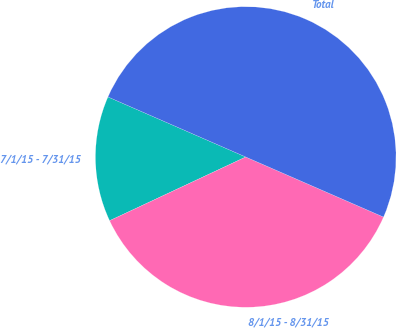Convert chart to OTSL. <chart><loc_0><loc_0><loc_500><loc_500><pie_chart><fcel>7/1/15 - 7/31/15<fcel>8/1/15 - 8/31/15<fcel>Total<nl><fcel>13.51%<fcel>36.49%<fcel>50.0%<nl></chart> 